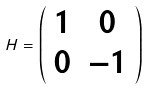<formula> <loc_0><loc_0><loc_500><loc_500>H = \left ( \begin{array} { c c } 1 & 0 \\ 0 & - 1 \end{array} \right )</formula> 